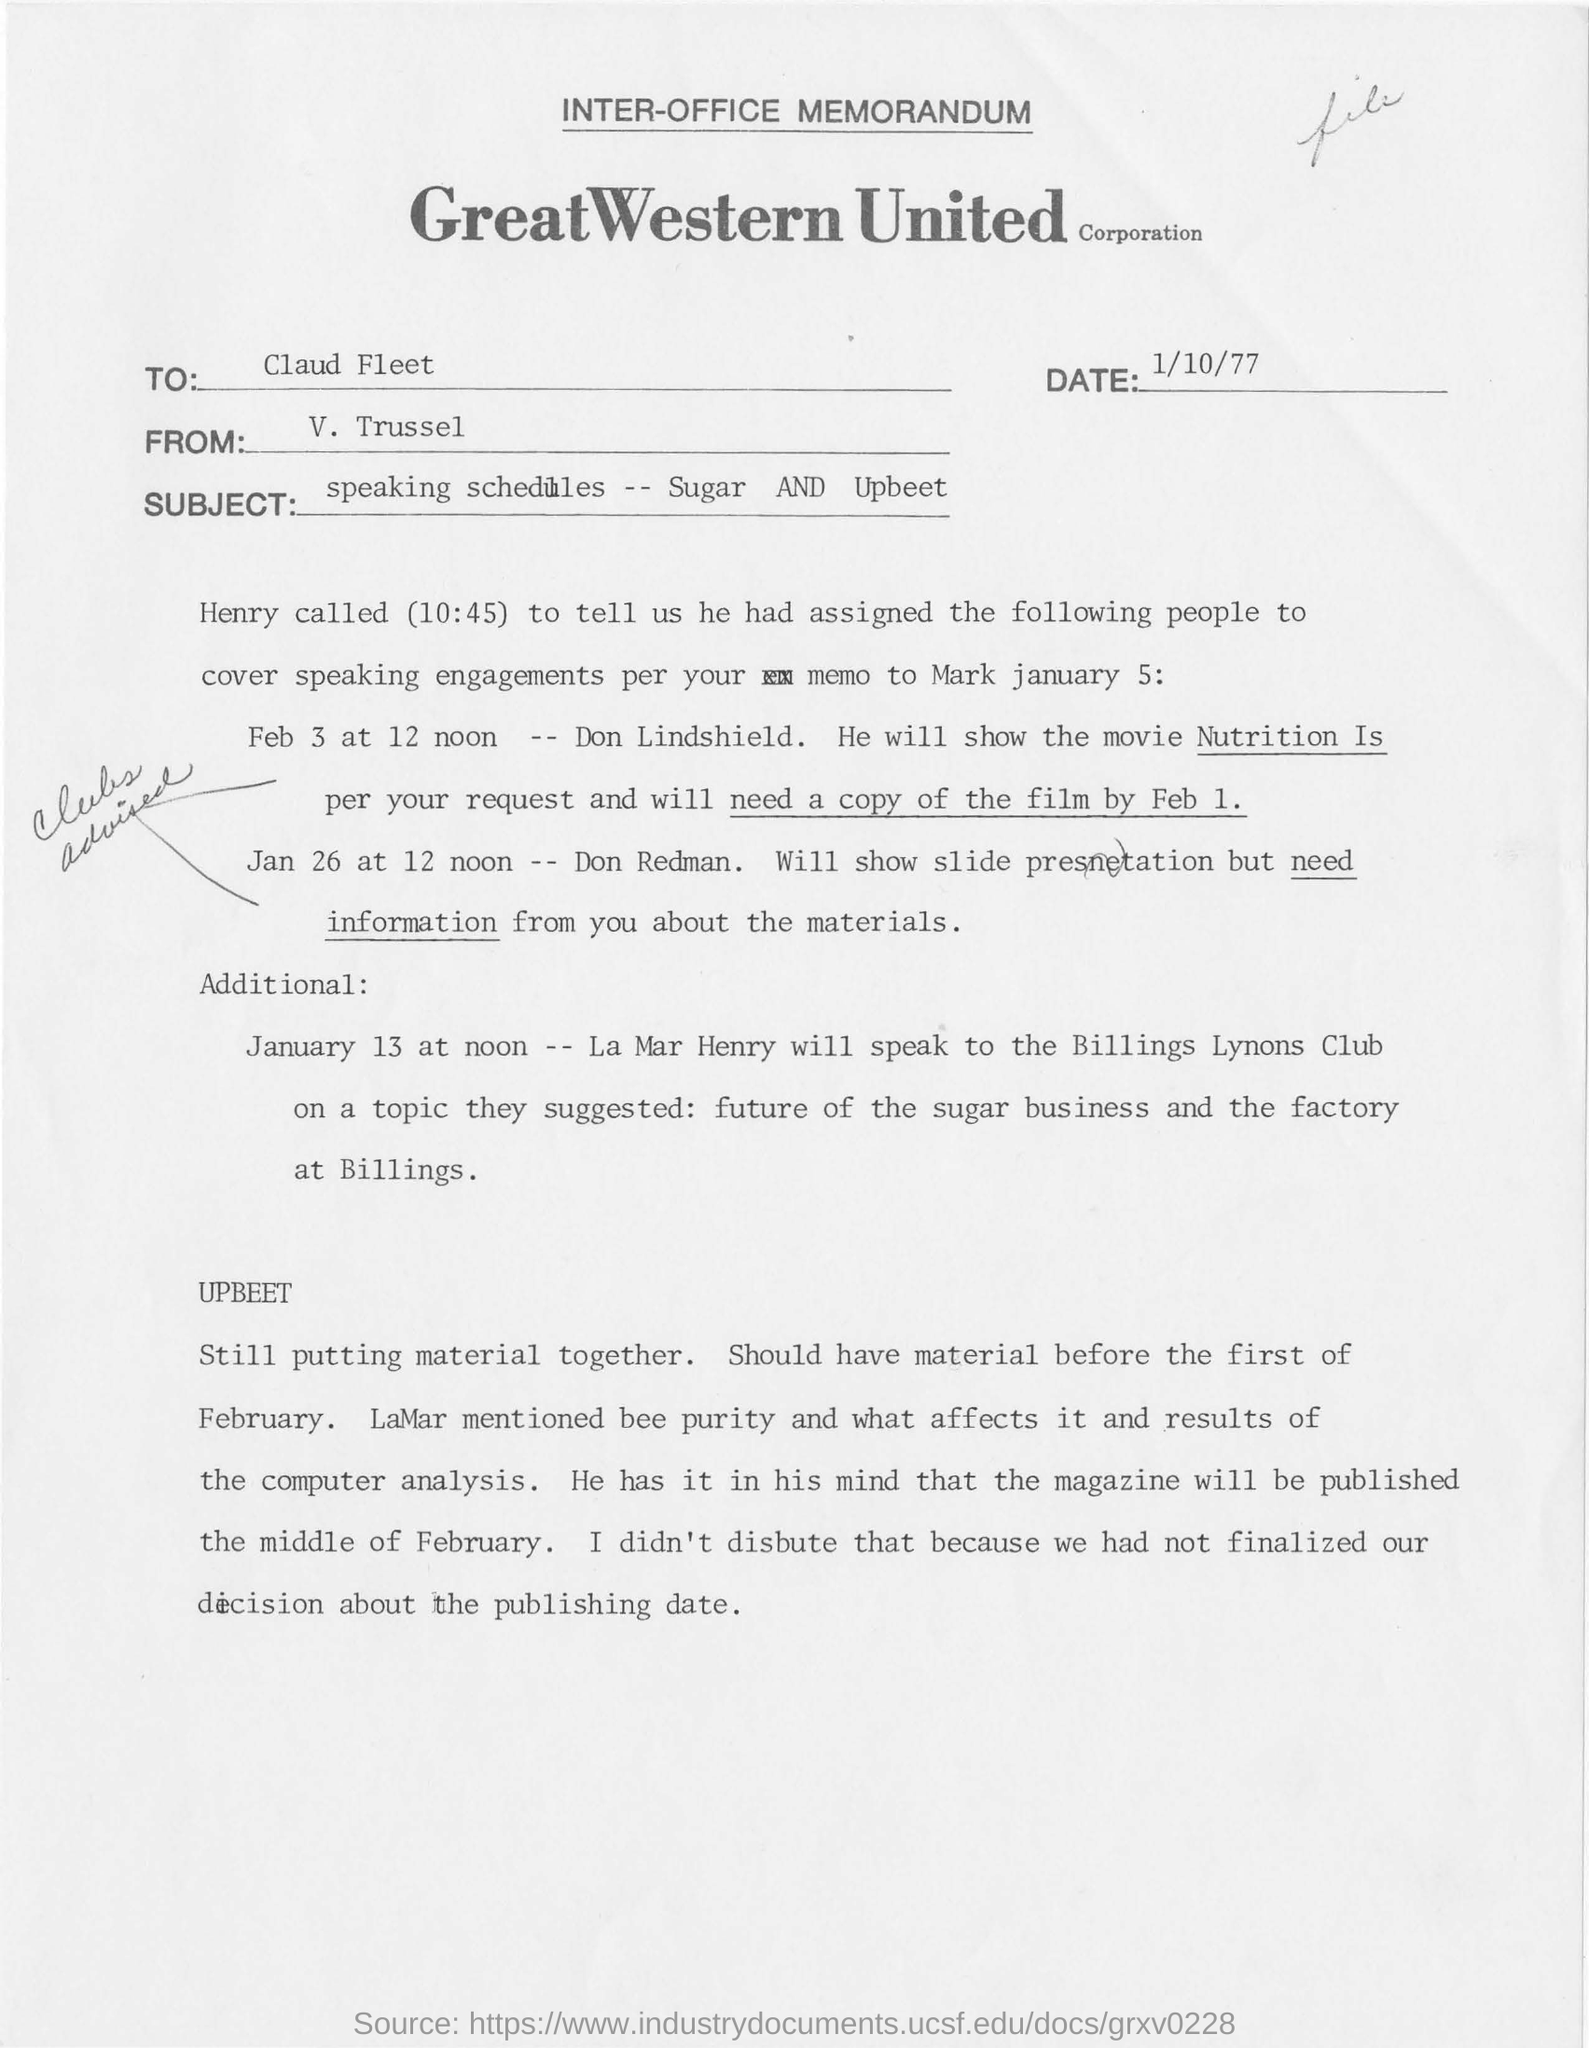Give some essential details in this illustration. The subject of the inter-office memorandum is "Speaking Schedules -- Sugar AND Upbeet. Great Western United Corporation is the name of a corporation. It is unknown who assigned the people to speak as per the memo, with Henry mentioned. The memorandum is being written by V. Trussel to Claud Fleet. On January 26 at 12 noon, the task of slide presentation is assigned to Don Redman. 